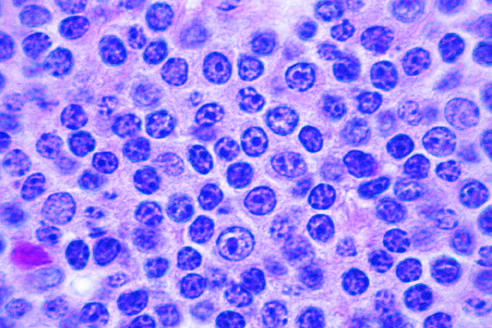what is a prolymphocyte?
Answer the question using a single word or phrase. A larger cell with a centrally placed nucleolus 